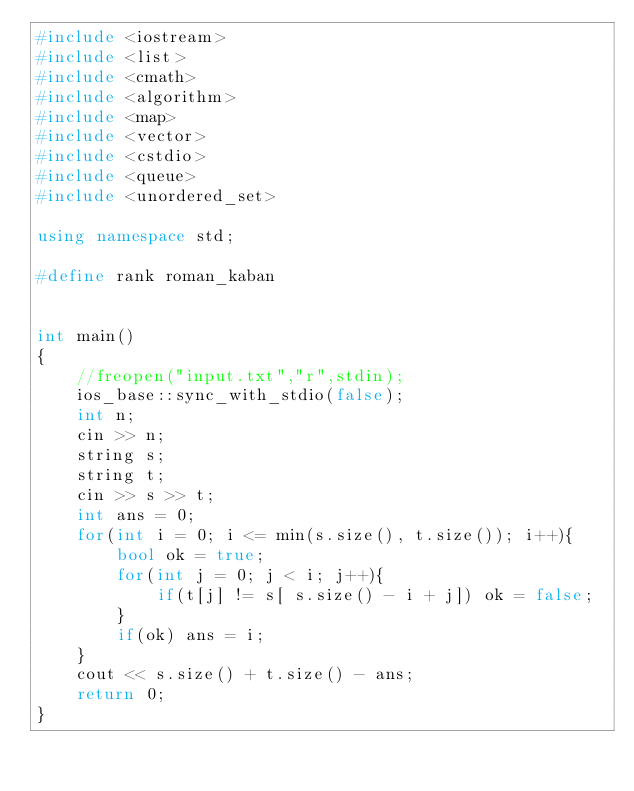Convert code to text. <code><loc_0><loc_0><loc_500><loc_500><_C++_>#include <iostream>
#include <list>
#include <cmath>
#include <algorithm>
#include <map>
#include <vector>
#include <cstdio>
#include <queue>
#include <unordered_set>

using namespace std;

#define rank roman_kaban


int main()
{
    //freopen("input.txt","r",stdin);
    ios_base::sync_with_stdio(false);
    int n;
    cin >> n;
    string s;
    string t;
    cin >> s >> t;
    int ans = 0;
    for(int i = 0; i <= min(s.size(), t.size()); i++){
        bool ok = true;
        for(int j = 0; j < i; j++){
            if(t[j] != s[ s.size() - i + j]) ok = false;
        }
        if(ok) ans = i;
    }
    cout << s.size() + t.size() - ans;
    return 0;
}
</code> 